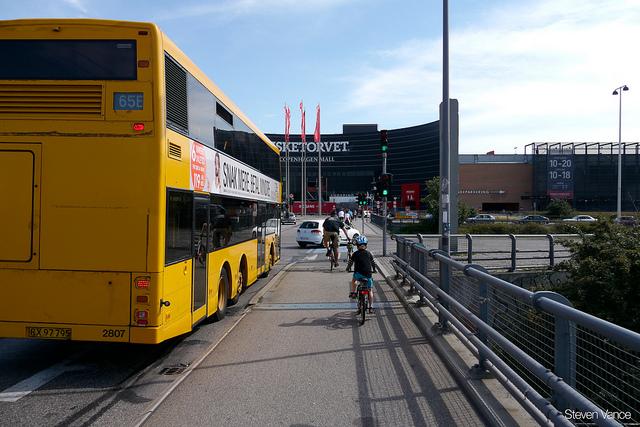What kind of weather it is?
Keep it brief. Sunny. What color is the bus?
Answer briefly. Yellow. What is the bus headed for?
Be succinct. Building ahead. 